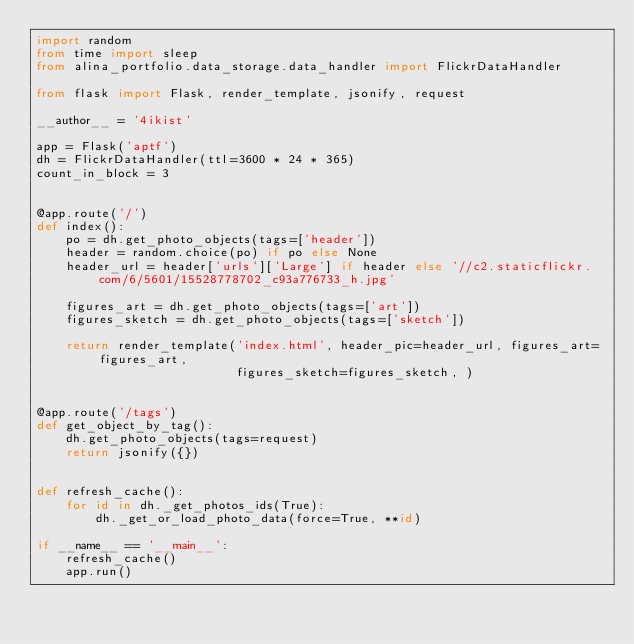<code> <loc_0><loc_0><loc_500><loc_500><_Python_>import random
from time import sleep
from alina_portfolio.data_storage.data_handler import FlickrDataHandler

from flask import Flask, render_template, jsonify, request

__author__ = '4ikist'

app = Flask('aptf')
dh = FlickrDataHandler(ttl=3600 * 24 * 365)
count_in_block = 3


@app.route('/')
def index():
    po = dh.get_photo_objects(tags=['header'])
    header = random.choice(po) if po else None
    header_url = header['urls']['Large'] if header else '//c2.staticflickr.com/6/5601/15528778702_c93a776733_h.jpg'

    figures_art = dh.get_photo_objects(tags=['art'])
    figures_sketch = dh.get_photo_objects(tags=['sketch'])

    return render_template('index.html', header_pic=header_url, figures_art=figures_art,
                           figures_sketch=figures_sketch, )


@app.route('/tags')
def get_object_by_tag():
    dh.get_photo_objects(tags=request)
    return jsonify({})


def refresh_cache():
    for id in dh._get_photos_ids(True):
        dh._get_or_load_photo_data(force=True, **id)

if __name__ == '__main__':
    refresh_cache()
    app.run()
</code> 